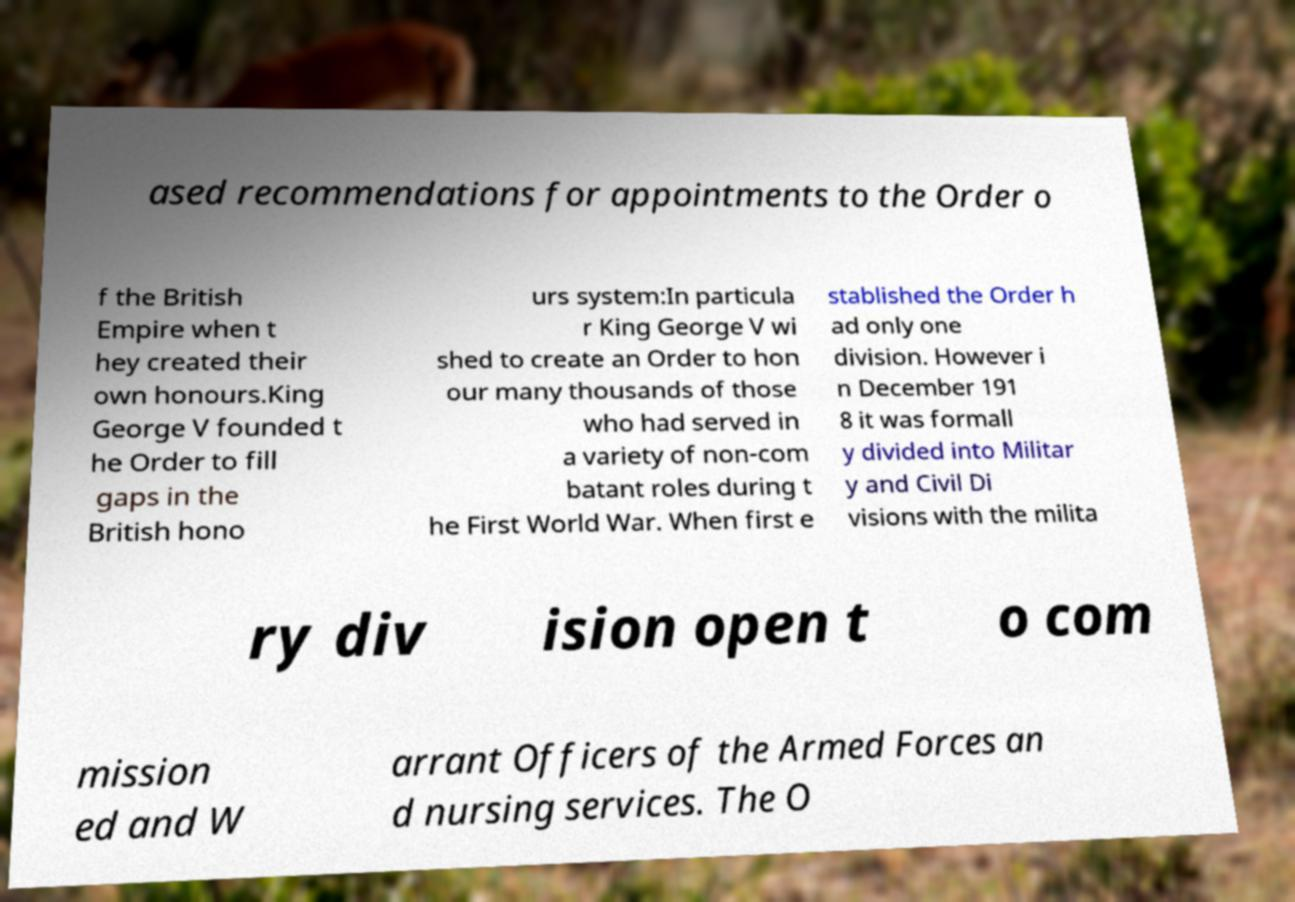Can you accurately transcribe the text from the provided image for me? ased recommendations for appointments to the Order o f the British Empire when t hey created their own honours.King George V founded t he Order to fill gaps in the British hono urs system:In particula r King George V wi shed to create an Order to hon our many thousands of those who had served in a variety of non-com batant roles during t he First World War. When first e stablished the Order h ad only one division. However i n December 191 8 it was formall y divided into Militar y and Civil Di visions with the milita ry div ision open t o com mission ed and W arrant Officers of the Armed Forces an d nursing services. The O 